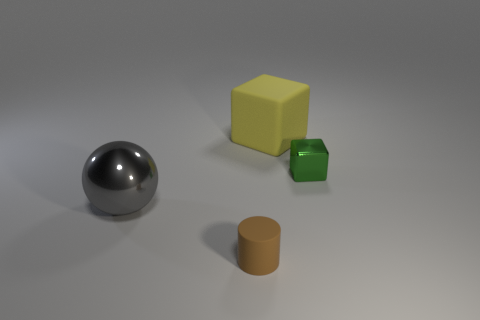Add 4 big yellow cubes. How many objects exist? 8 Subtract all yellow cubes. How many cubes are left? 1 Subtract all cylinders. How many objects are left? 3 Subtract all cyan balls. Subtract all brown cylinders. How many balls are left? 1 Subtract all small rubber cylinders. Subtract all large rubber cubes. How many objects are left? 2 Add 1 yellow objects. How many yellow objects are left? 2 Add 2 small things. How many small things exist? 4 Subtract 0 yellow cylinders. How many objects are left? 4 